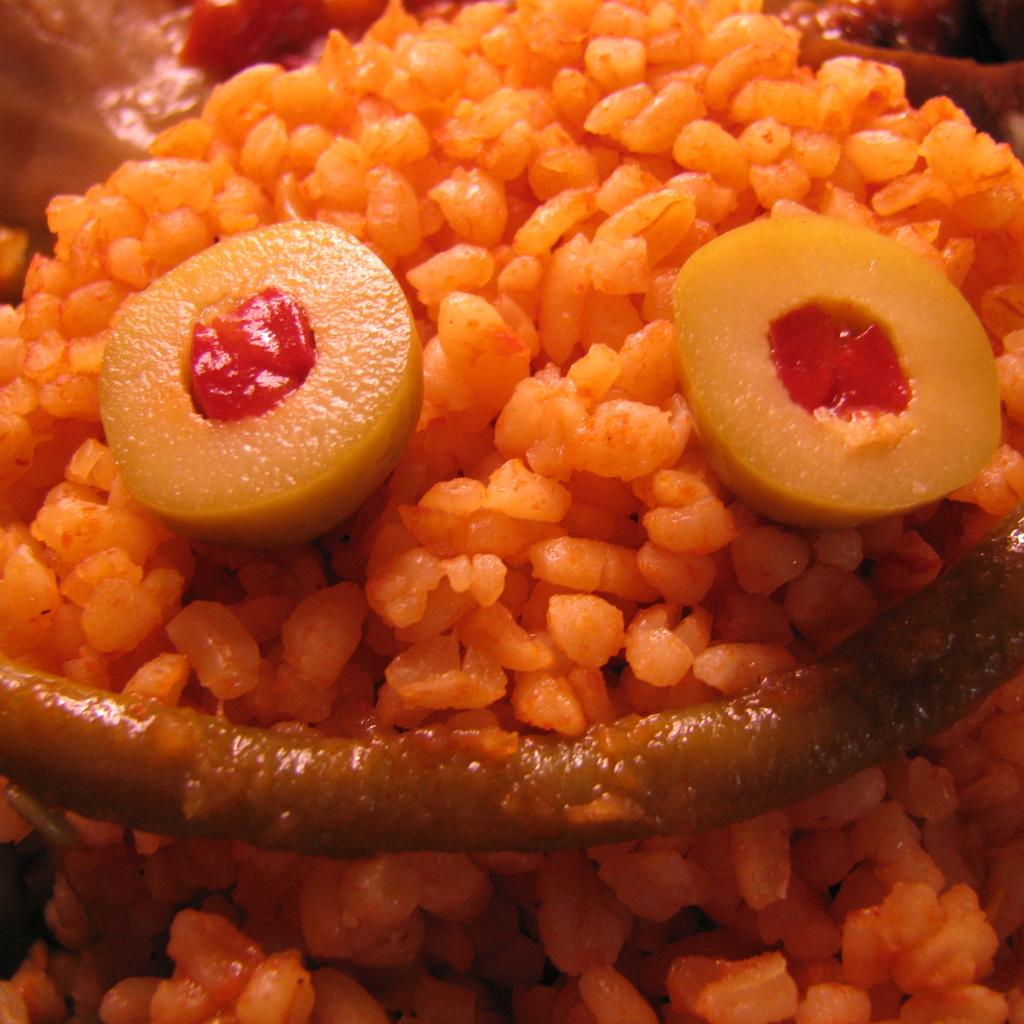What can be seen in the image? There is food visible in the image. Where is the bath located in the image? There is no bath present in the image. What type of scissors can be seen cutting the food in the image? There are no scissors or any cutting action depicted in the image. 